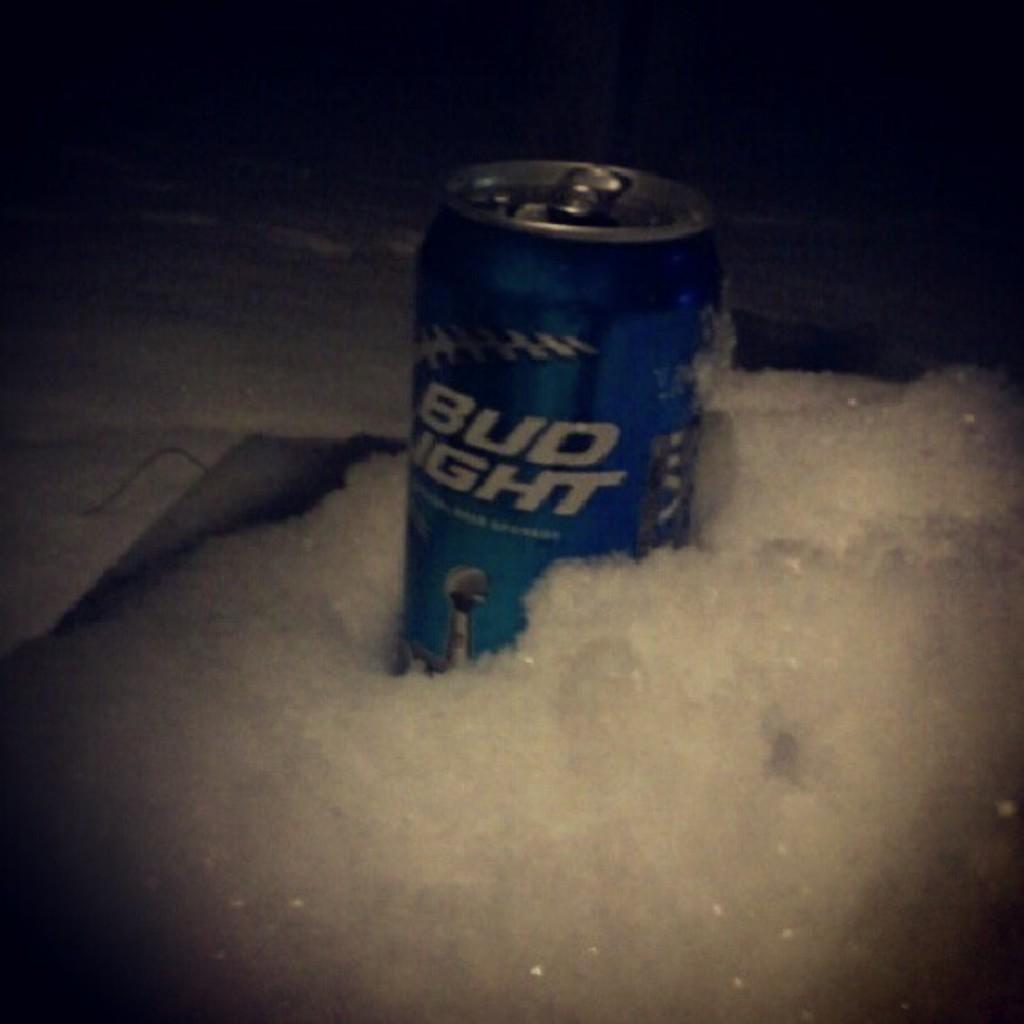What brand beer is in this can?
Ensure brevity in your answer.  Bud light. What is the first word on the can?
Provide a short and direct response. Bud. 